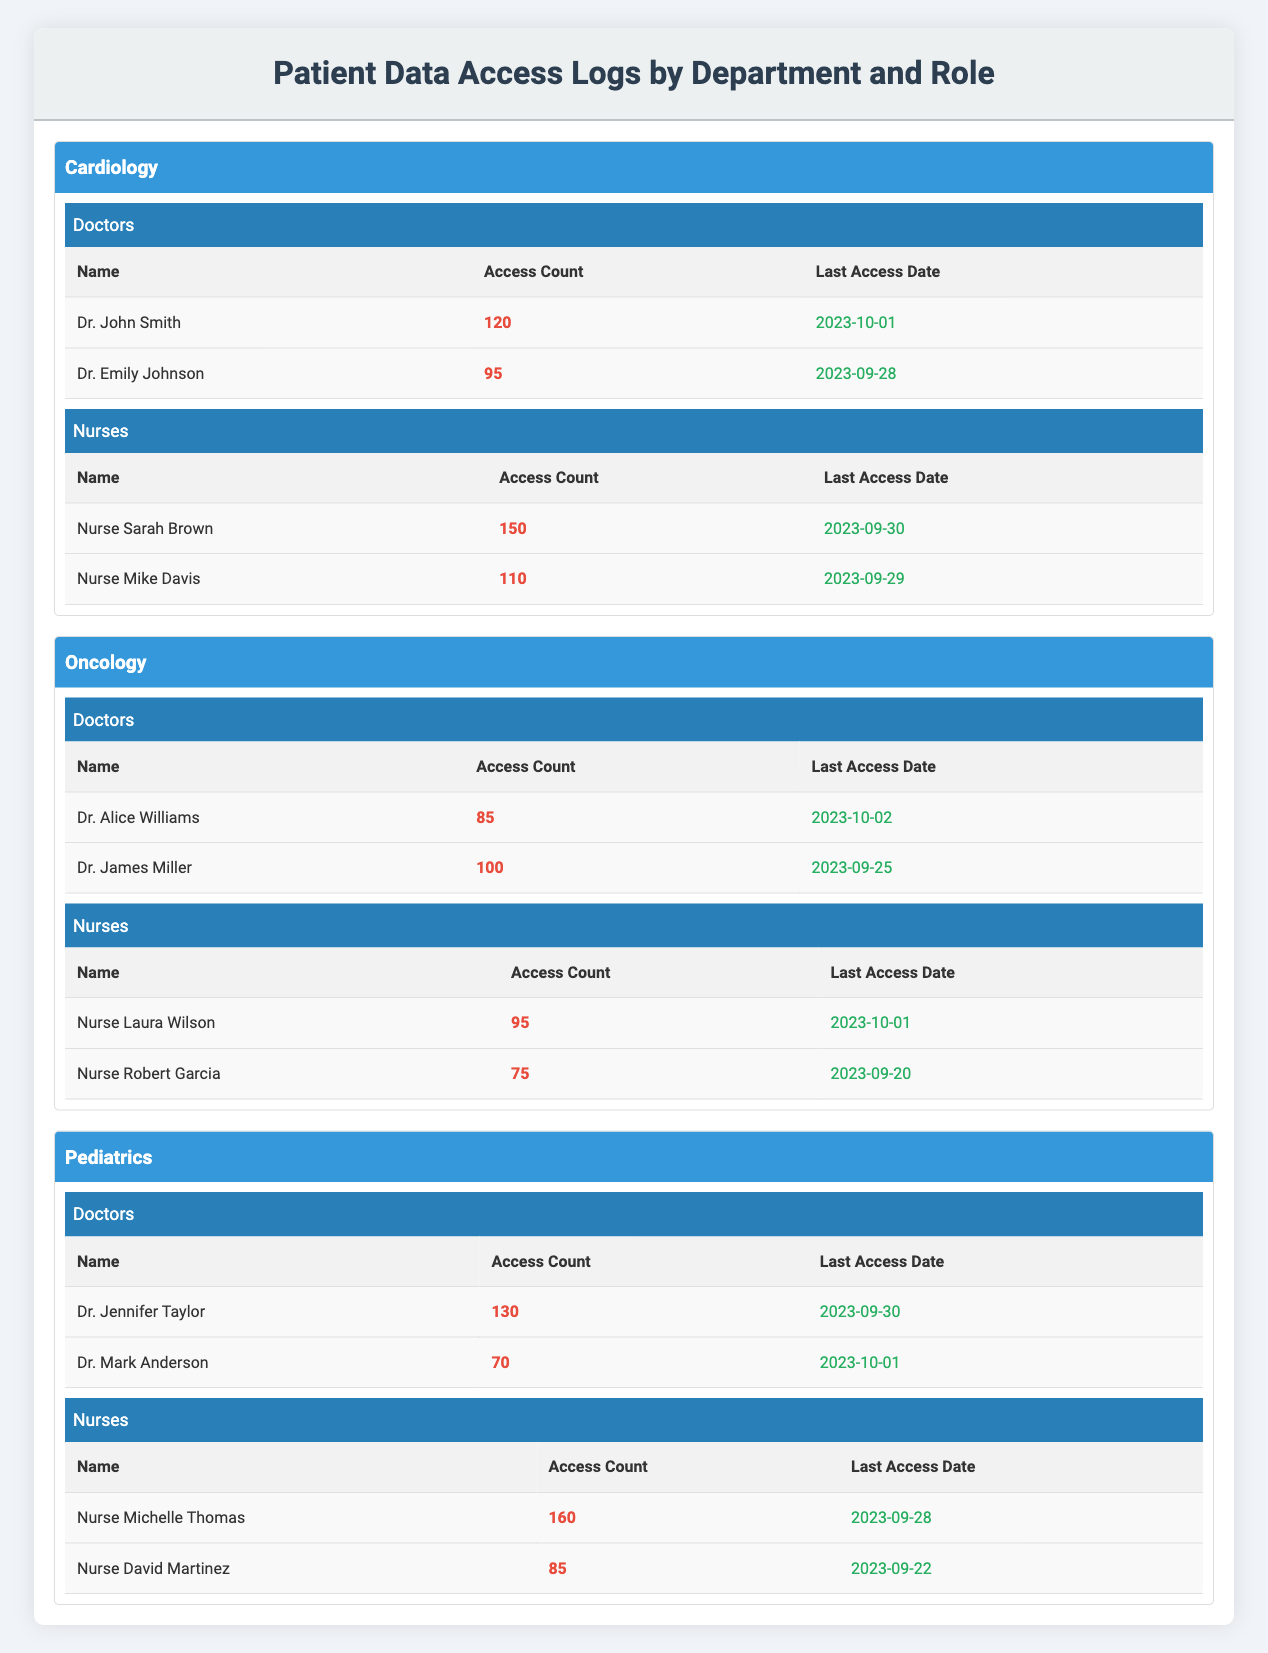What is the highest access count among the doctors in Cardiology? The highest access count for doctors in Cardiology is found by comparing both counts: Dr. John Smith has 120 and Dr. Emily Johnson has 95. Therefore, 120 is the highest.
Answer: 120 Which nurse in Pediatrics had the most recent access date? To find this, I compare the last access dates of Nurse Michelle Thomas (2023-09-28) and Nurse David Martinez (2023-09-22). Since 2023-09-28 is later than 2023-09-22, Nurse Michelle Thomas had the most recent access date.
Answer: Nurse Michelle Thomas How many times did nurses access patient data in Cardiology in total? The total access count for nurses in Cardiology is calculated by adding their access counts: 150 (Nurse Sarah Brown) + 110 (Nurse Mike Davis) = 260.
Answer: 260 Did Dr. Alice Williams access patient data more times than Nurse Laura Wilson? Dr. Alice Williams accessed data 85 times, while Nurse Laura Wilson accessed data 95 times. Since 85 is less than 95, Dr. Alice Williams did not access more.
Answer: No What is the average access count for doctors in the Oncology department? To find the average, add the access counts for Dr. Alice Williams (85) and Dr. James Miller (100): 85 + 100 = 185. Divide by the number of doctors, which is 2: 185 / 2 = 92.5.
Answer: 92.5 Which department had the highest access count for nurses? First, calculate the nursing access counts for each department: Cardiology (150 + 110 = 260), Oncology (95 + 75 = 170), and Pediatrics (160 + 85 = 245). The highest total is 260 in Cardiology.
Answer: Cardiology What was the last access date for Dr. Mark Anderson? The last access date for Dr. Mark Anderson is listed in the table as 2023-10-01.
Answer: 2023-10-01 Is it true that Nurse Robert Garcia accessed patient data more times than Dr. Emily Johnson? Nurse Robert Garcia has an access count of 75, and Dr. Emily Johnson has an access count of 95. Since 75 is less than 95, it is not true.
Answer: No 